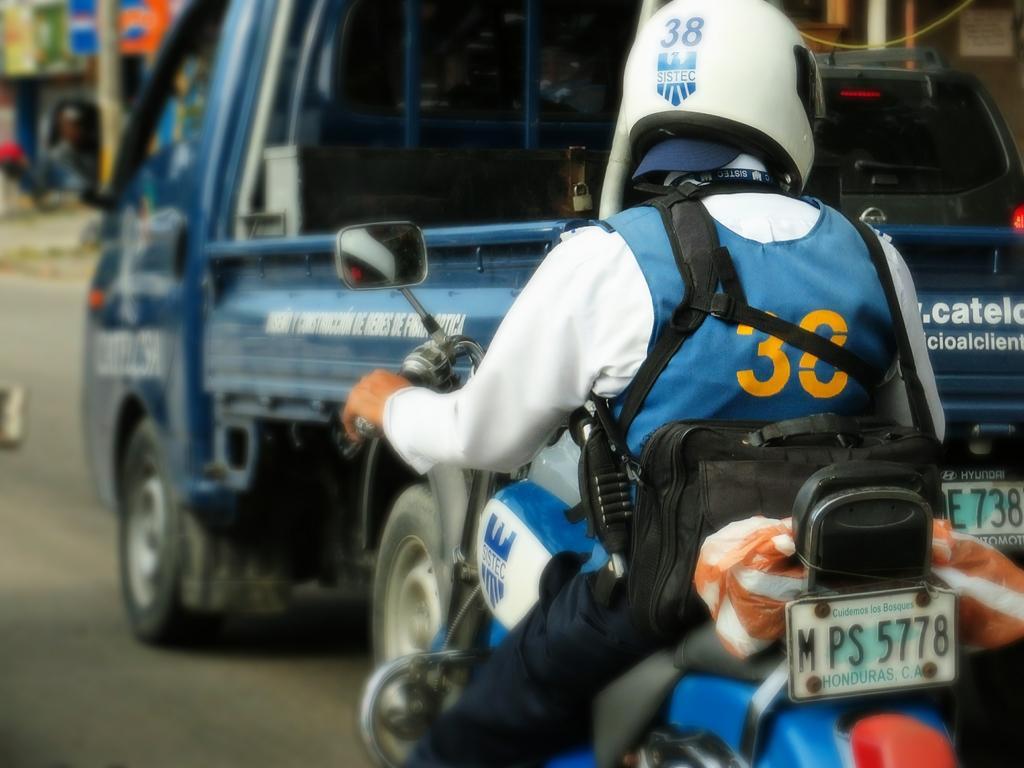Describe this image in one or two sentences. On the right side, there is a person in a white color shirt, wearing a helmet, riding a bike on the road, on which there is a vehicle. And the background is blurred. 